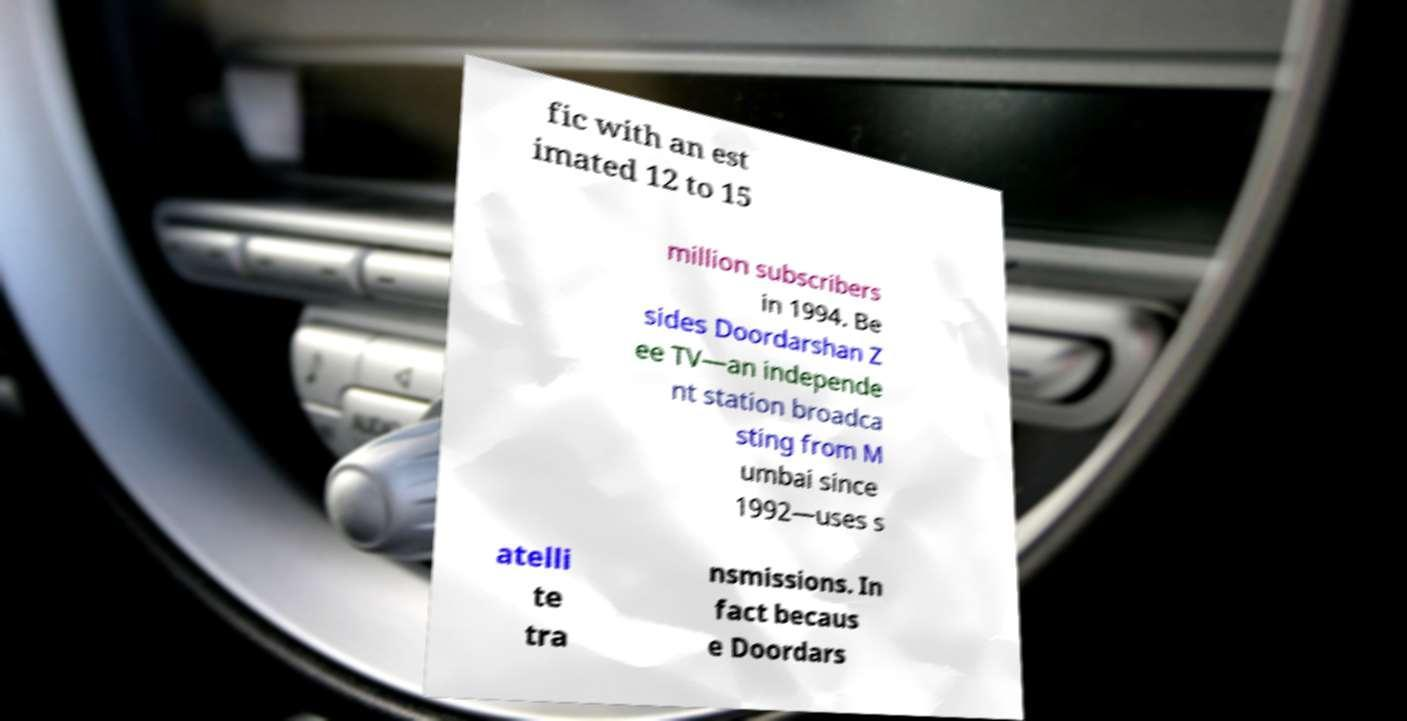Can you accurately transcribe the text from the provided image for me? fic with an est imated 12 to 15 million subscribers in 1994. Be sides Doordarshan Z ee TV—an independe nt station broadca sting from M umbai since 1992—uses s atelli te tra nsmissions. In fact becaus e Doordars 